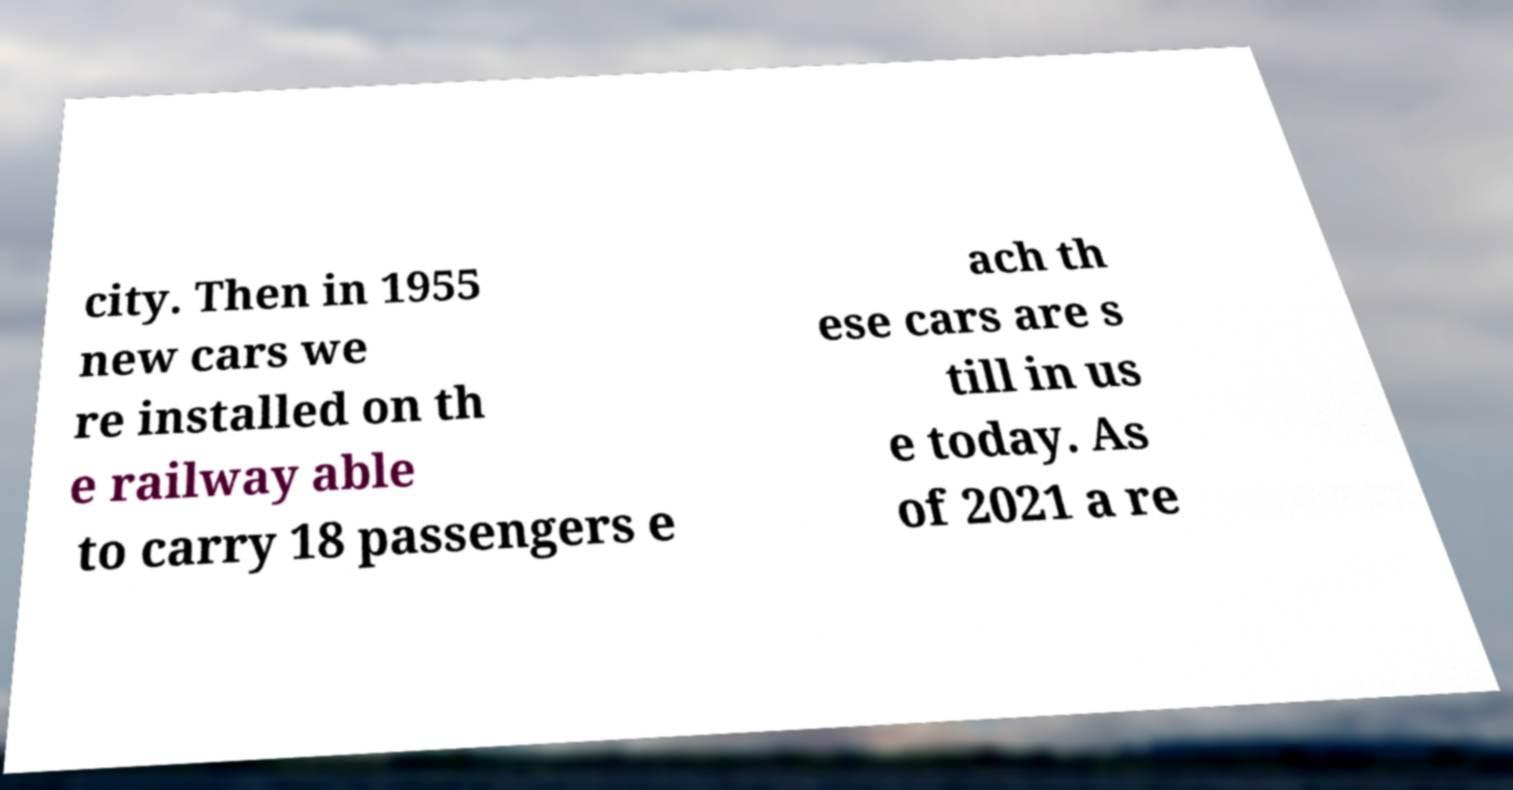Can you accurately transcribe the text from the provided image for me? city. Then in 1955 new cars we re installed on th e railway able to carry 18 passengers e ach th ese cars are s till in us e today. As of 2021 a re 